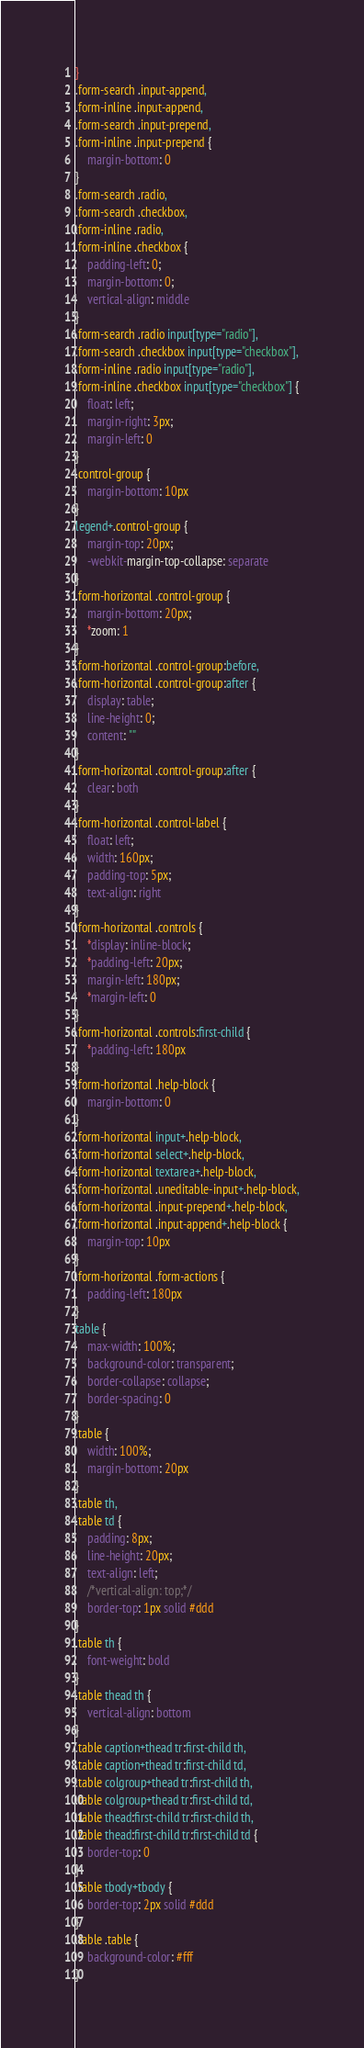Convert code to text. <code><loc_0><loc_0><loc_500><loc_500><_CSS_>}
.form-search .input-append,
.form-inline .input-append,
.form-search .input-prepend,
.form-inline .input-prepend {
    margin-bottom: 0
}
.form-search .radio,
.form-search .checkbox,
.form-inline .radio,
.form-inline .checkbox {
    padding-left: 0;
    margin-bottom: 0;
    vertical-align: middle
}
.form-search .radio input[type="radio"],
.form-search .checkbox input[type="checkbox"],
.form-inline .radio input[type="radio"],
.form-inline .checkbox input[type="checkbox"] {
    float: left;
    margin-right: 3px;
    margin-left: 0
}
.control-group {
    margin-bottom: 10px
}
legend+.control-group {
    margin-top: 20px;
    -webkit-margin-top-collapse: separate
}
.form-horizontal .control-group {
    margin-bottom: 20px;
    *zoom: 1
}
.form-horizontal .control-group:before,
.form-horizontal .control-group:after {
    display: table;
    line-height: 0;
    content: ""
}
.form-horizontal .control-group:after {
    clear: both
}
.form-horizontal .control-label {
    float: left;
    width: 160px;
    padding-top: 5px;
    text-align: right
}
.form-horizontal .controls {
    *display: inline-block;
    *padding-left: 20px;
    margin-left: 180px;
    *margin-left: 0
}
.form-horizontal .controls:first-child {
    *padding-left: 180px
}
.form-horizontal .help-block {
    margin-bottom: 0
}
.form-horizontal input+.help-block,
.form-horizontal select+.help-block,
.form-horizontal textarea+.help-block,
.form-horizontal .uneditable-input+.help-block,
.form-horizontal .input-prepend+.help-block,
.form-horizontal .input-append+.help-block {
    margin-top: 10px
}
.form-horizontal .form-actions {
    padding-left: 180px
}
table {
    max-width: 100%;
    background-color: transparent;
    border-collapse: collapse;
    border-spacing: 0
}
.table {
    width: 100%;
    margin-bottom: 20px
}
.table th,
.table td {
    padding: 8px;
    line-height: 20px;
    text-align: left;
    /*vertical-align: top;*/
    border-top: 1px solid #ddd
}
.table th {
    font-weight: bold
}
.table thead th {
    vertical-align: bottom
}
.table caption+thead tr:first-child th,
.table caption+thead tr:first-child td,
.table colgroup+thead tr:first-child th,
.table colgroup+thead tr:first-child td,
.table thead:first-child tr:first-child th,
.table thead:first-child tr:first-child td {
    border-top: 0
}
.table tbody+tbody {
    border-top: 2px solid #ddd
}
.table .table {
    background-color: #fff
}</code> 